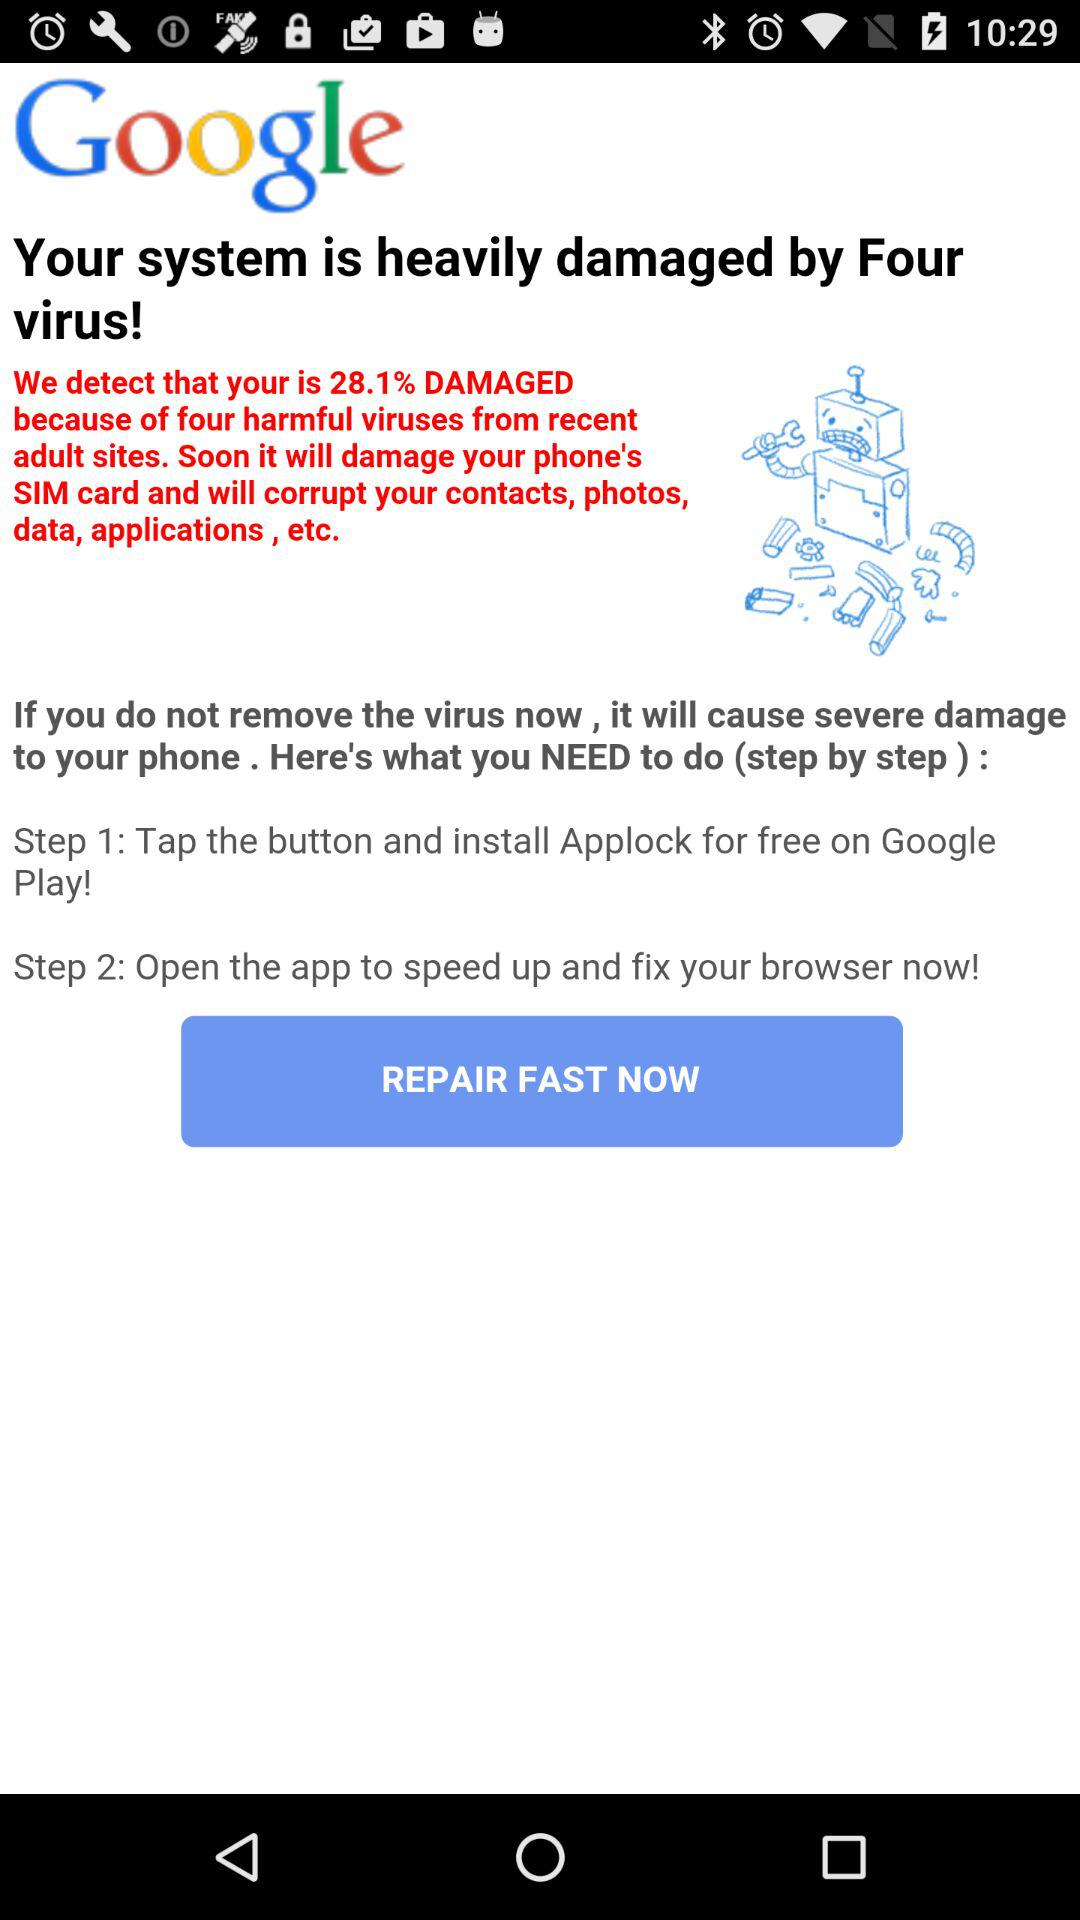What is the name of the application? The names of the applications are "Google", "Applock" and "Google Play". 